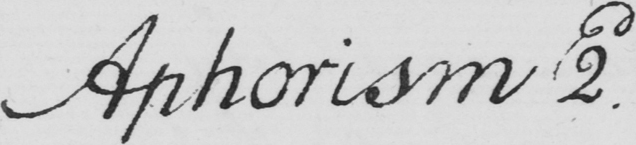What text is written in this handwritten line? Aphorism 2d 